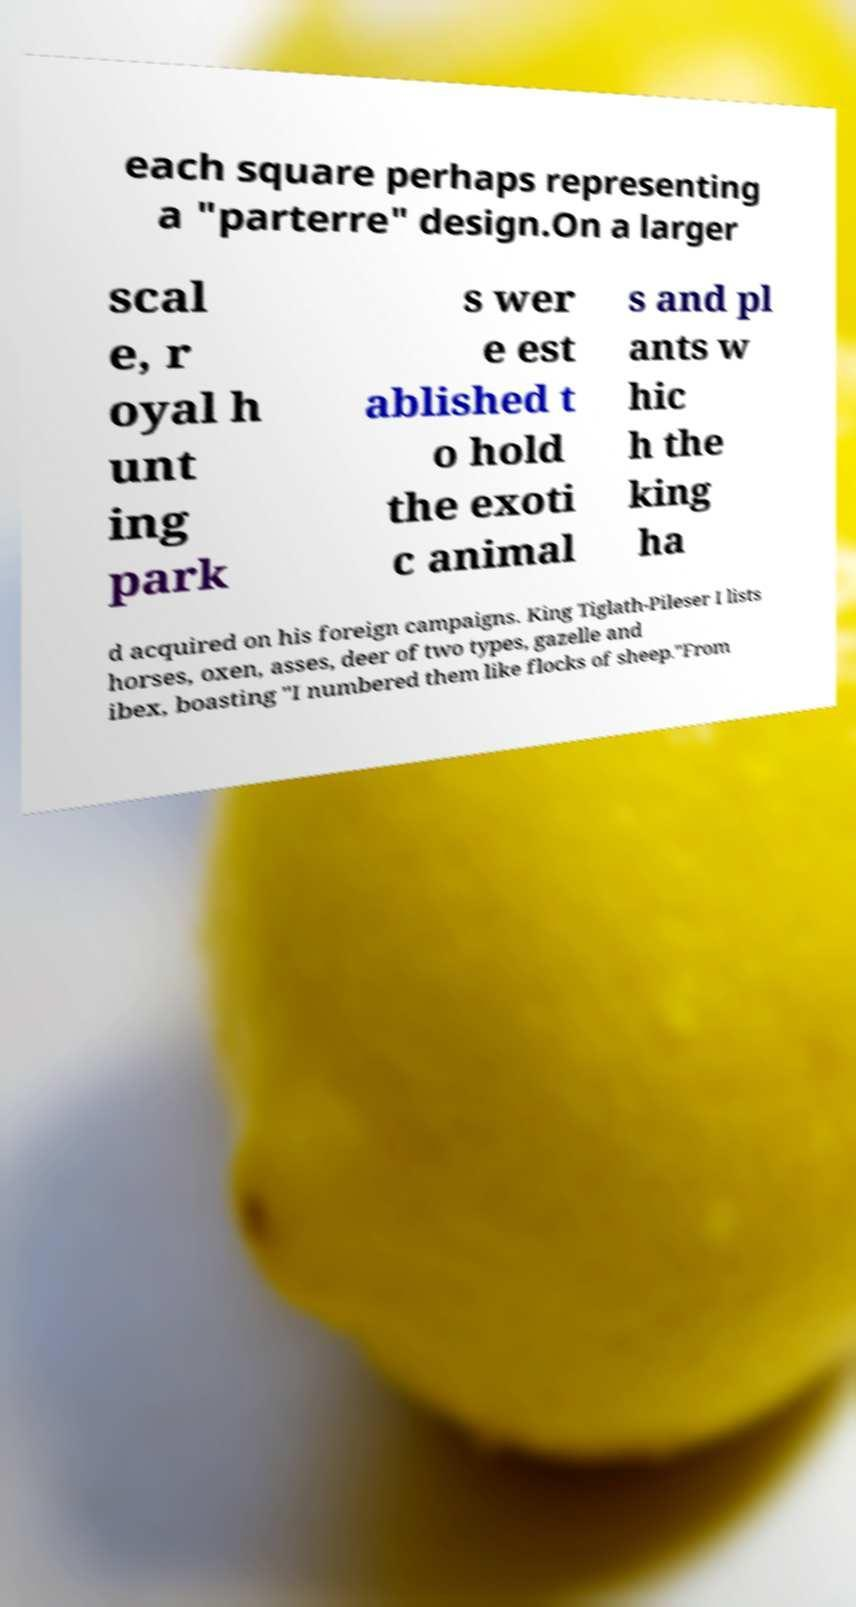Please identify and transcribe the text found in this image. each square perhaps representing a "parterre" design.On a larger scal e, r oyal h unt ing park s wer e est ablished t o hold the exoti c animal s and pl ants w hic h the king ha d acquired on his foreign campaigns. King Tiglath-Pileser I lists horses, oxen, asses, deer of two types, gazelle and ibex, boasting "I numbered them like flocks of sheep."From 